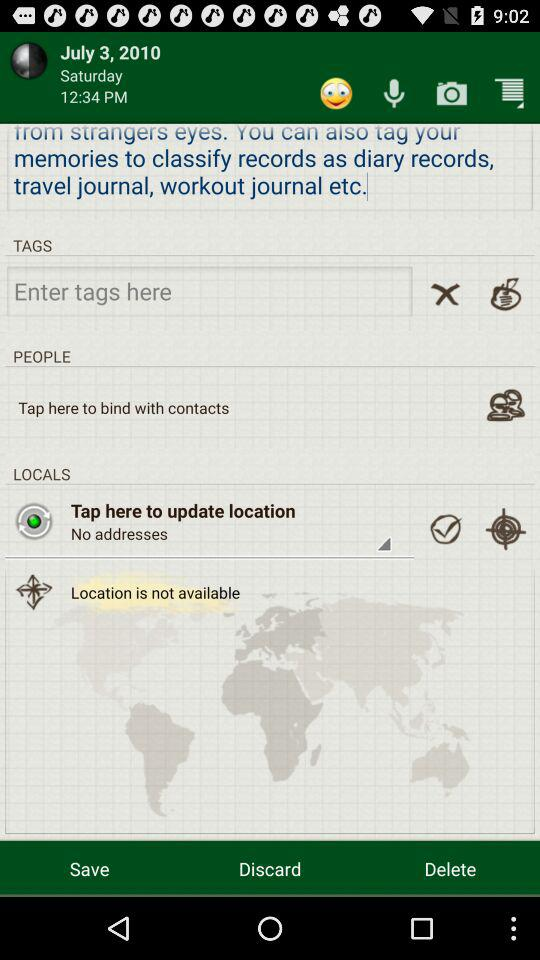What date and time are mentioned? The mentioned date is Saturday, July 3, 2010 and the time is 12:34 PM. 